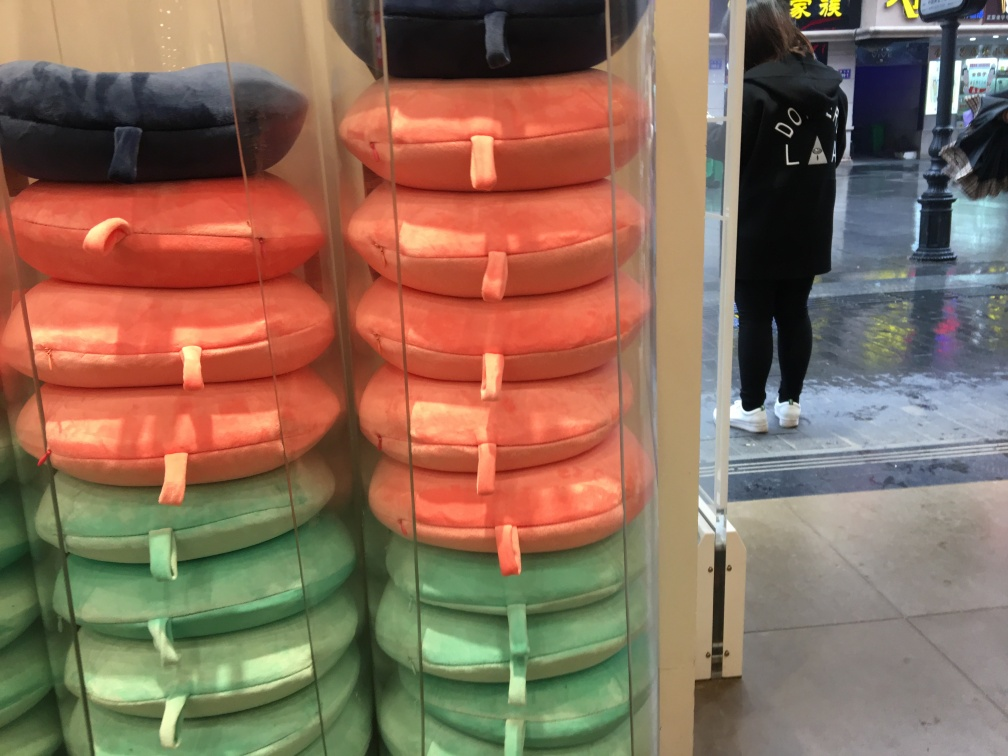What is the quality of this image?
A. good
B. excellent
C. average
D. poor Assessing the quality of the image provided, I would classify its quality as average (Option C). The image appears to be somewhat blurry with noticeable grain, which makes it less than ideal in terms of sharpness and clarity. However, it is still clear enough to make out the stacked travel pillows and the person in the background, which suggests that important details remain distinguishable. 